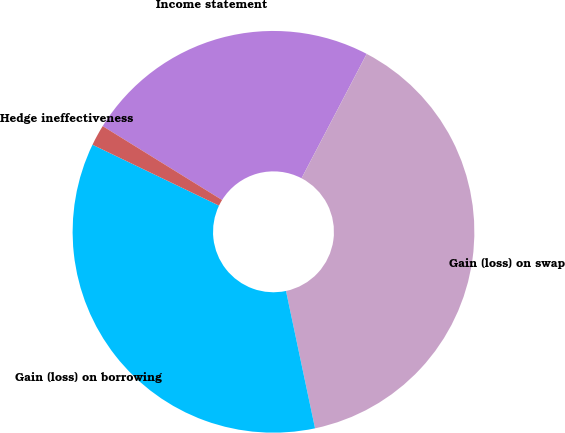<chart> <loc_0><loc_0><loc_500><loc_500><pie_chart><fcel>Income statement<fcel>Gain (loss) on swap<fcel>Gain (loss) on borrowing<fcel>Hedge ineffectiveness<nl><fcel>23.86%<fcel>39.0%<fcel>35.45%<fcel>1.68%<nl></chart> 